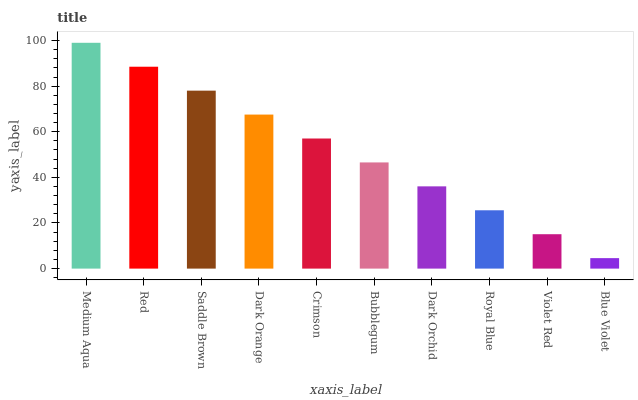Is Blue Violet the minimum?
Answer yes or no. Yes. Is Medium Aqua the maximum?
Answer yes or no. Yes. Is Red the minimum?
Answer yes or no. No. Is Red the maximum?
Answer yes or no. No. Is Medium Aqua greater than Red?
Answer yes or no. Yes. Is Red less than Medium Aqua?
Answer yes or no. Yes. Is Red greater than Medium Aqua?
Answer yes or no. No. Is Medium Aqua less than Red?
Answer yes or no. No. Is Crimson the high median?
Answer yes or no. Yes. Is Bubblegum the low median?
Answer yes or no. Yes. Is Medium Aqua the high median?
Answer yes or no. No. Is Red the low median?
Answer yes or no. No. 